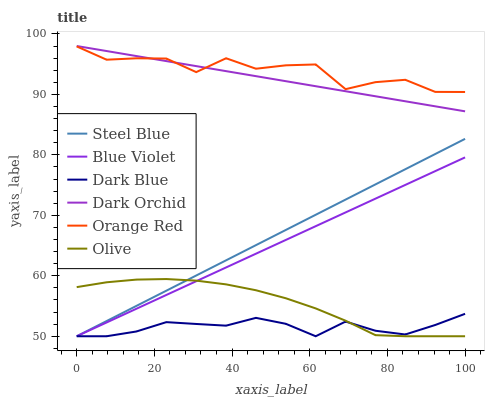Does Dark Orchid have the minimum area under the curve?
Answer yes or no. No. Does Dark Orchid have the maximum area under the curve?
Answer yes or no. No. Is Dark Orchid the smoothest?
Answer yes or no. No. Is Dark Orchid the roughest?
Answer yes or no. No. Does Dark Orchid have the lowest value?
Answer yes or no. No. Does Dark Blue have the highest value?
Answer yes or no. No. Is Steel Blue less than Orange Red?
Answer yes or no. Yes. Is Orange Red greater than Steel Blue?
Answer yes or no. Yes. Does Steel Blue intersect Orange Red?
Answer yes or no. No. 